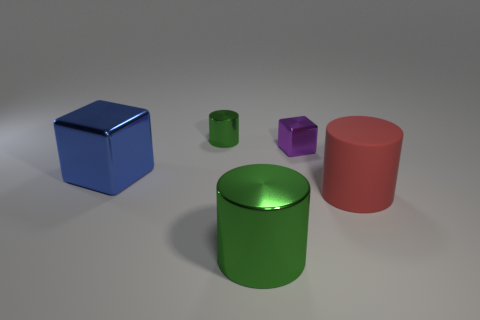How many green cylinders must be subtracted to get 1 green cylinders? 1 Subtract all big red cylinders. How many cylinders are left? 2 Add 1 big green cylinders. How many objects exist? 6 Subtract all red cylinders. How many cylinders are left? 2 Subtract all red spheres. How many green cylinders are left? 2 Subtract all cubes. How many objects are left? 3 Subtract 2 cubes. How many cubes are left? 0 Subtract all brown blocks. Subtract all blue balls. How many blocks are left? 2 Subtract all metallic cubes. Subtract all small things. How many objects are left? 1 Add 1 red cylinders. How many red cylinders are left? 2 